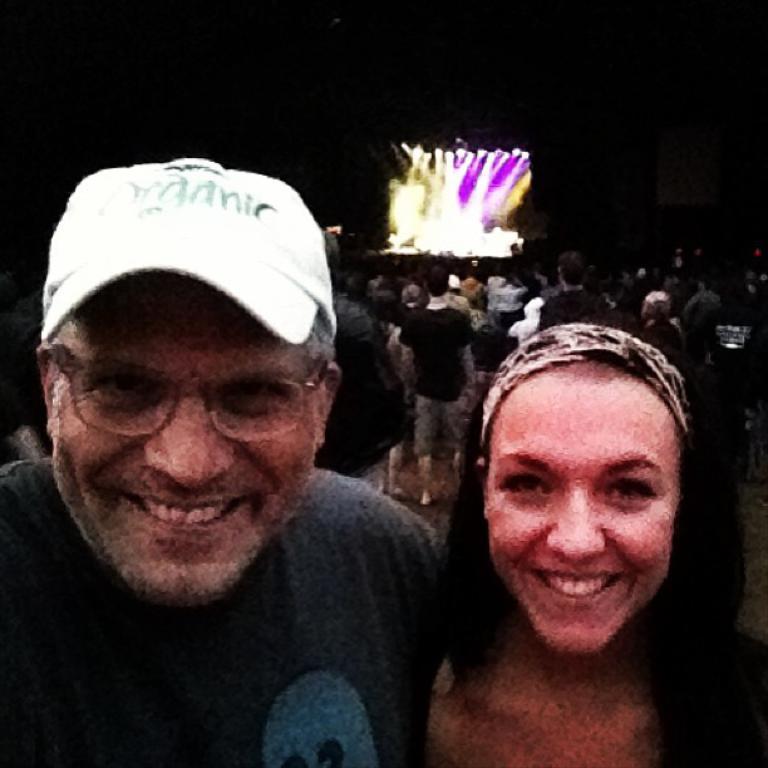Describe this image in one or two sentences. This picture describes about group of people, in the foreground we can see a man and woman, they both are smiling, in the background we can see lights. 